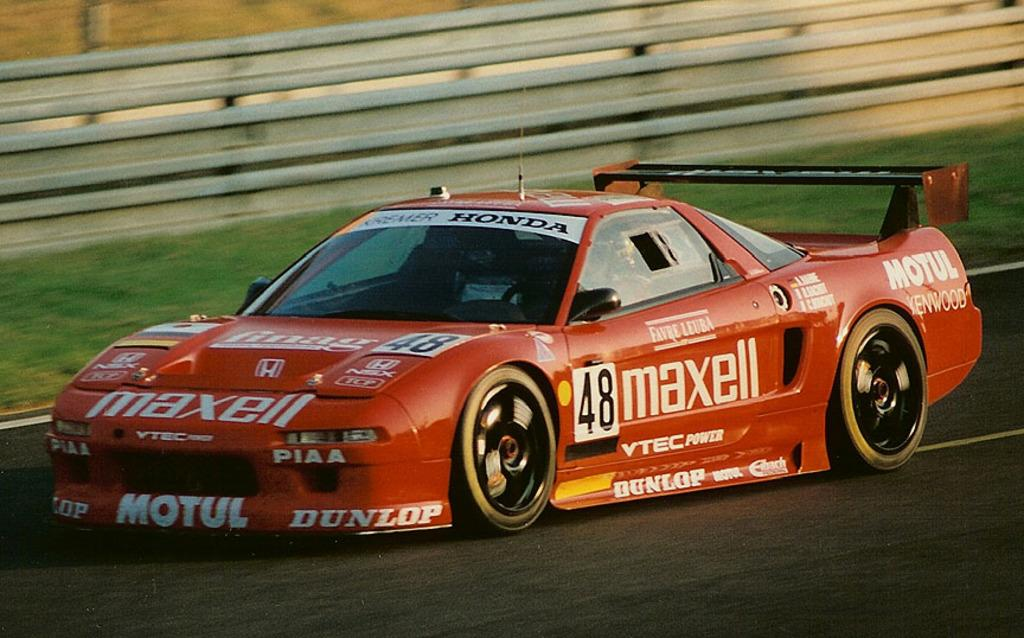What is the person in the image doing? There is a person riding a car in the image. Where is the car located? The car is on the road. What can be seen in the background of the image? There is a fence visible in the background of the image. What type of ground is visible in the image? There is grass on the ground in the image. How many elbows can be seen in the image? There are no elbows visible in the image, as it only features a person riding a car on the road. 